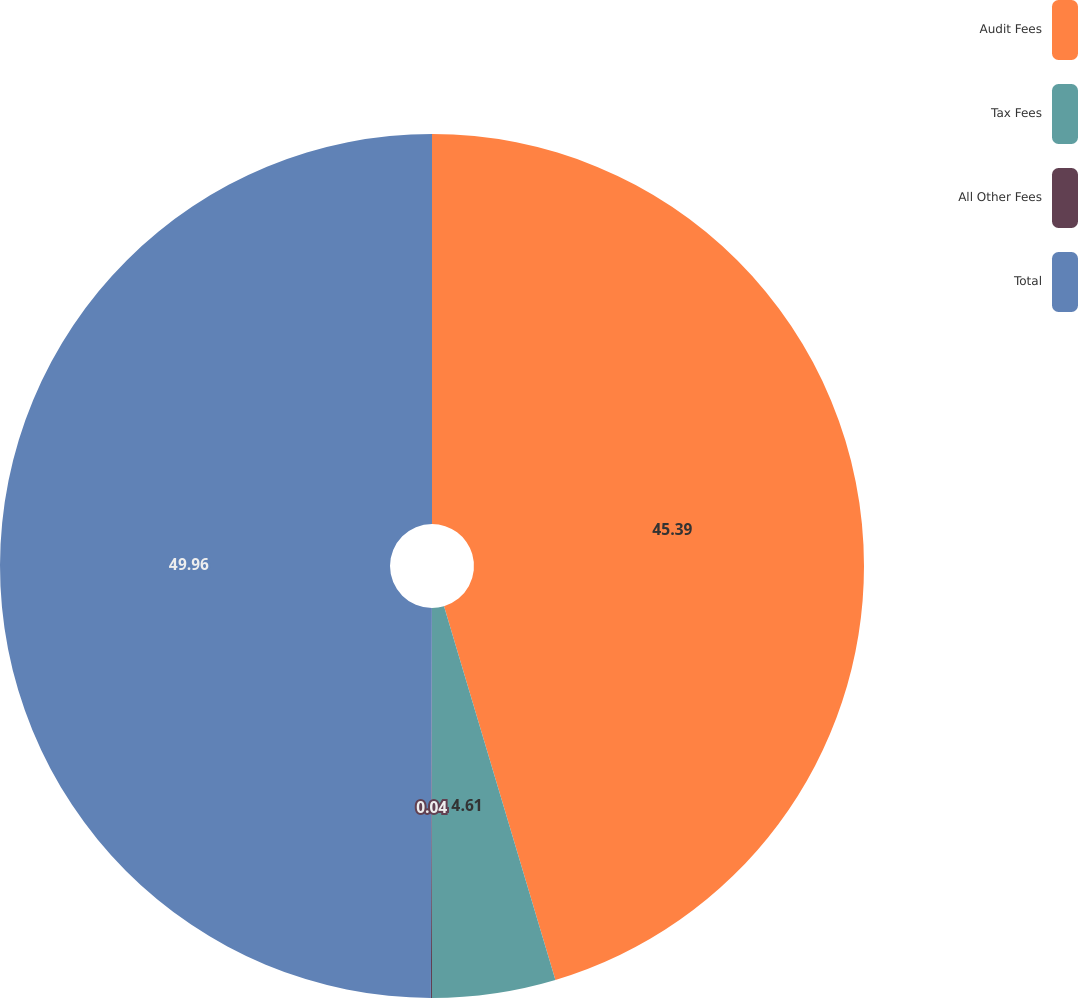Convert chart. <chart><loc_0><loc_0><loc_500><loc_500><pie_chart><fcel>Audit Fees<fcel>Tax Fees<fcel>All Other Fees<fcel>Total<nl><fcel>45.39%<fcel>4.61%<fcel>0.04%<fcel>49.96%<nl></chart> 